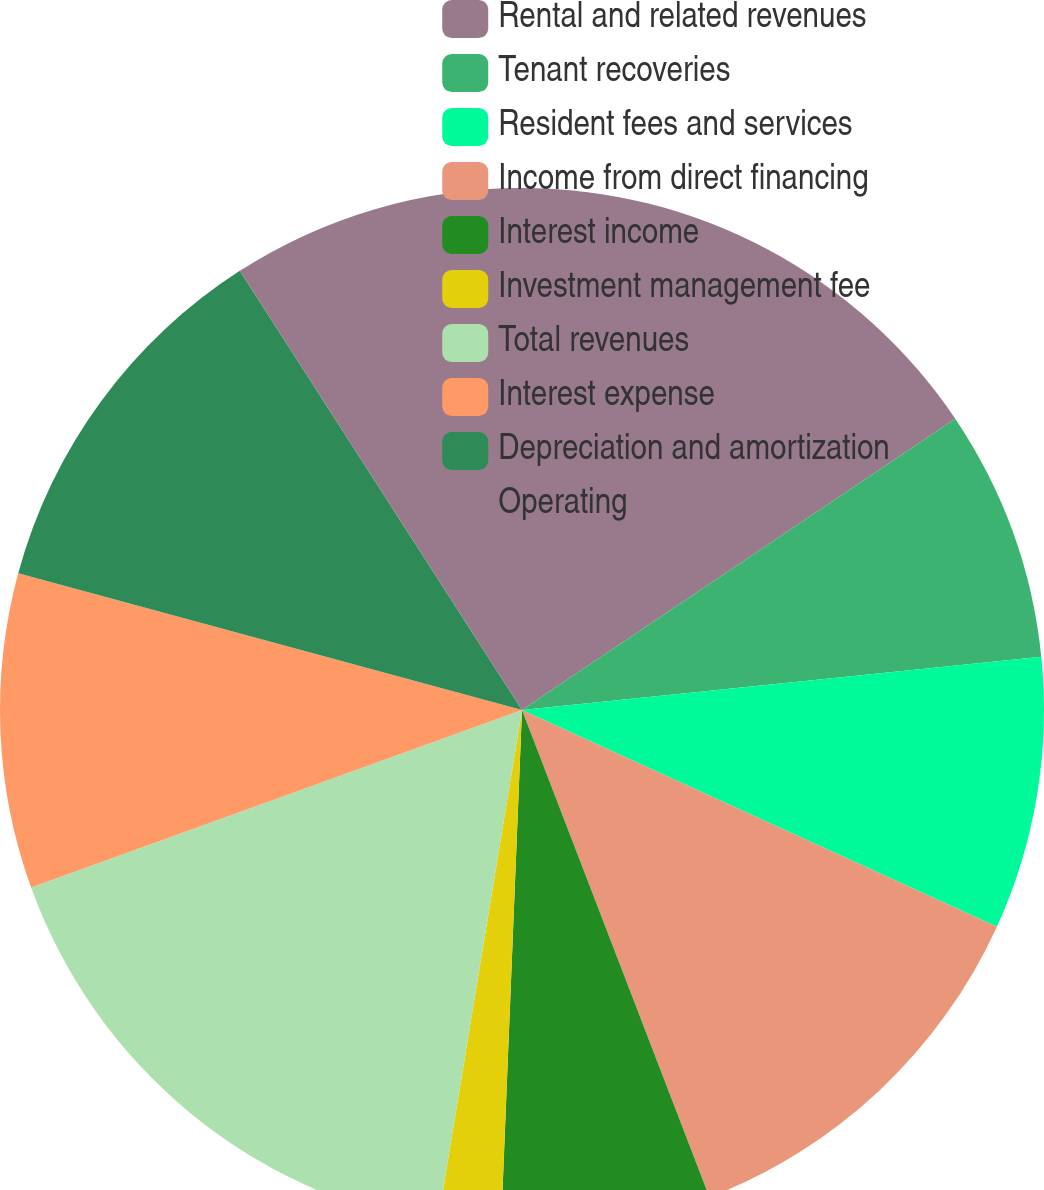<chart> <loc_0><loc_0><loc_500><loc_500><pie_chart><fcel>Rental and related revenues<fcel>Tenant recoveries<fcel>Resident fees and services<fcel>Income from direct financing<fcel>Interest income<fcel>Investment management fee<fcel>Total revenues<fcel>Interest expense<fcel>Depreciation and amortization<fcel>Operating<nl><fcel>15.58%<fcel>7.79%<fcel>8.44%<fcel>12.34%<fcel>6.49%<fcel>1.95%<fcel>16.88%<fcel>9.74%<fcel>11.69%<fcel>9.09%<nl></chart> 